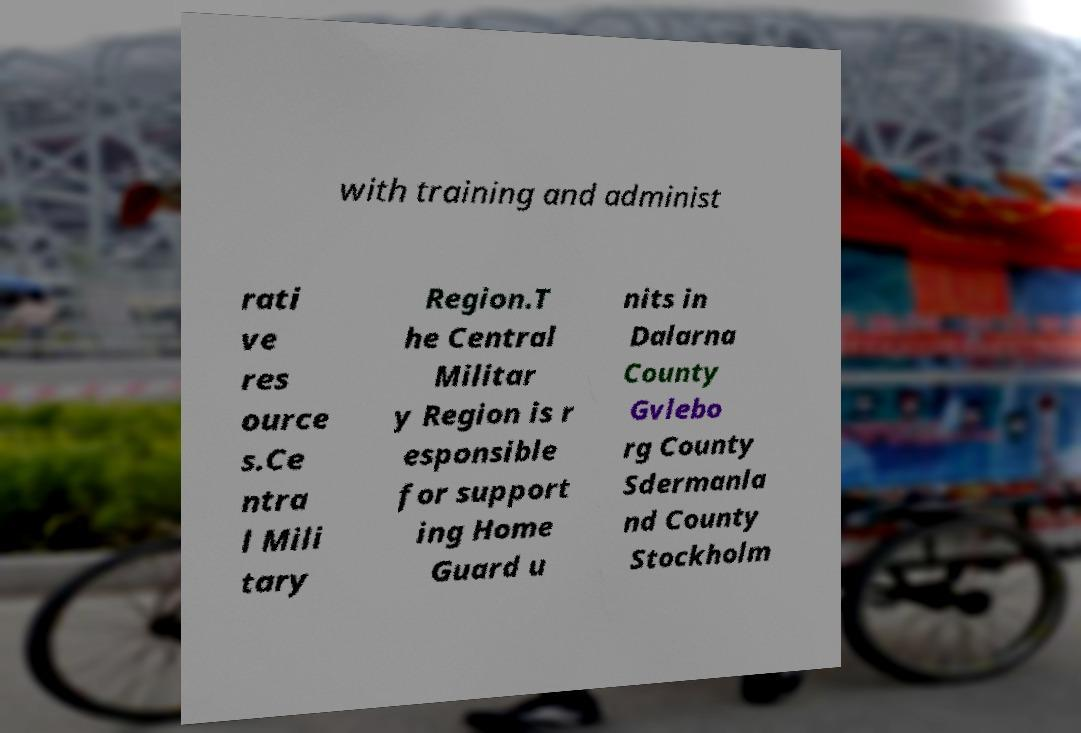Could you extract and type out the text from this image? with training and administ rati ve res ource s.Ce ntra l Mili tary Region.T he Central Militar y Region is r esponsible for support ing Home Guard u nits in Dalarna County Gvlebo rg County Sdermanla nd County Stockholm 